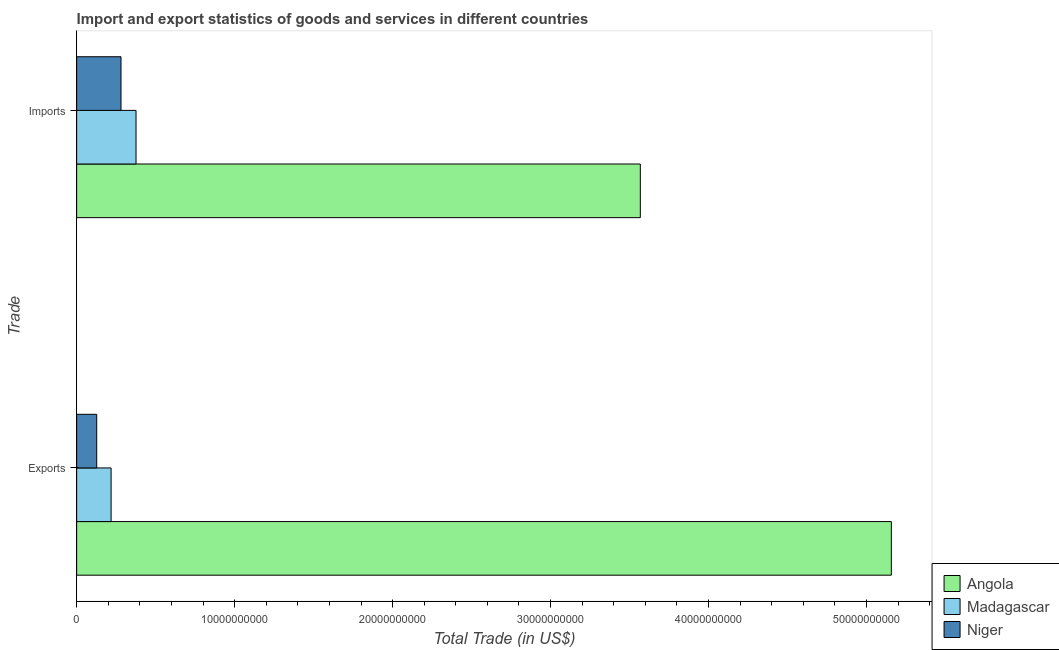How many groups of bars are there?
Provide a short and direct response. 2. Are the number of bars per tick equal to the number of legend labels?
Provide a succinct answer. Yes. Are the number of bars on each tick of the Y-axis equal?
Keep it short and to the point. Yes. How many bars are there on the 2nd tick from the bottom?
Provide a succinct answer. 3. What is the label of the 1st group of bars from the top?
Provide a succinct answer. Imports. What is the imports of goods and services in Madagascar?
Make the answer very short. 3.76e+09. Across all countries, what is the maximum imports of goods and services?
Keep it short and to the point. 3.57e+1. Across all countries, what is the minimum export of goods and services?
Your response must be concise. 1.27e+09. In which country was the imports of goods and services maximum?
Keep it short and to the point. Angola. In which country was the imports of goods and services minimum?
Make the answer very short. Niger. What is the total export of goods and services in the graph?
Make the answer very short. 5.50e+1. What is the difference between the imports of goods and services in Madagascar and that in Niger?
Your response must be concise. 9.51e+08. What is the difference between the imports of goods and services in Madagascar and the export of goods and services in Niger?
Your answer should be compact. 2.49e+09. What is the average export of goods and services per country?
Make the answer very short. 1.83e+1. What is the difference between the imports of goods and services and export of goods and services in Madagascar?
Your response must be concise. 1.58e+09. In how many countries, is the export of goods and services greater than 14000000000 US$?
Give a very brief answer. 1. What is the ratio of the imports of goods and services in Niger to that in Madagascar?
Your response must be concise. 0.75. In how many countries, is the export of goods and services greater than the average export of goods and services taken over all countries?
Provide a succinct answer. 1. What does the 3rd bar from the top in Exports represents?
Make the answer very short. Angola. What does the 3rd bar from the bottom in Imports represents?
Keep it short and to the point. Niger. How many bars are there?
Provide a short and direct response. 6. Are all the bars in the graph horizontal?
Offer a very short reply. Yes. How many countries are there in the graph?
Your answer should be very brief. 3. What is the difference between two consecutive major ticks on the X-axis?
Offer a terse response. 1.00e+1. Are the values on the major ticks of X-axis written in scientific E-notation?
Provide a short and direct response. No. Does the graph contain any zero values?
Provide a short and direct response. No. Does the graph contain grids?
Your answer should be very brief. No. How many legend labels are there?
Provide a succinct answer. 3. How are the legend labels stacked?
Provide a short and direct response. Vertical. What is the title of the graph?
Your answer should be compact. Import and export statistics of goods and services in different countries. What is the label or title of the X-axis?
Provide a short and direct response. Total Trade (in US$). What is the label or title of the Y-axis?
Offer a terse response. Trade. What is the Total Trade (in US$) in Angola in Exports?
Give a very brief answer. 5.16e+1. What is the Total Trade (in US$) in Madagascar in Exports?
Offer a terse response. 2.18e+09. What is the Total Trade (in US$) of Niger in Exports?
Ensure brevity in your answer.  1.27e+09. What is the Total Trade (in US$) in Angola in Imports?
Your answer should be very brief. 3.57e+1. What is the Total Trade (in US$) of Madagascar in Imports?
Your response must be concise. 3.76e+09. What is the Total Trade (in US$) in Niger in Imports?
Offer a terse response. 2.81e+09. Across all Trade, what is the maximum Total Trade (in US$) in Angola?
Ensure brevity in your answer.  5.16e+1. Across all Trade, what is the maximum Total Trade (in US$) in Madagascar?
Offer a terse response. 3.76e+09. Across all Trade, what is the maximum Total Trade (in US$) in Niger?
Your answer should be compact. 2.81e+09. Across all Trade, what is the minimum Total Trade (in US$) in Angola?
Provide a succinct answer. 3.57e+1. Across all Trade, what is the minimum Total Trade (in US$) in Madagascar?
Offer a very short reply. 2.18e+09. Across all Trade, what is the minimum Total Trade (in US$) of Niger?
Ensure brevity in your answer.  1.27e+09. What is the total Total Trade (in US$) of Angola in the graph?
Ensure brevity in your answer.  8.73e+1. What is the total Total Trade (in US$) of Madagascar in the graph?
Your response must be concise. 5.94e+09. What is the total Total Trade (in US$) of Niger in the graph?
Offer a very short reply. 4.08e+09. What is the difference between the Total Trade (in US$) in Angola in Exports and that in Imports?
Offer a terse response. 1.59e+1. What is the difference between the Total Trade (in US$) in Madagascar in Exports and that in Imports?
Ensure brevity in your answer.  -1.58e+09. What is the difference between the Total Trade (in US$) of Niger in Exports and that in Imports?
Your response must be concise. -1.54e+09. What is the difference between the Total Trade (in US$) of Angola in Exports and the Total Trade (in US$) of Madagascar in Imports?
Keep it short and to the point. 4.78e+1. What is the difference between the Total Trade (in US$) of Angola in Exports and the Total Trade (in US$) of Niger in Imports?
Give a very brief answer. 4.88e+1. What is the difference between the Total Trade (in US$) of Madagascar in Exports and the Total Trade (in US$) of Niger in Imports?
Your response must be concise. -6.27e+08. What is the average Total Trade (in US$) of Angola per Trade?
Offer a terse response. 4.36e+1. What is the average Total Trade (in US$) of Madagascar per Trade?
Your response must be concise. 2.97e+09. What is the average Total Trade (in US$) in Niger per Trade?
Offer a terse response. 2.04e+09. What is the difference between the Total Trade (in US$) of Angola and Total Trade (in US$) of Madagascar in Exports?
Give a very brief answer. 4.94e+1. What is the difference between the Total Trade (in US$) in Angola and Total Trade (in US$) in Niger in Exports?
Offer a very short reply. 5.03e+1. What is the difference between the Total Trade (in US$) in Madagascar and Total Trade (in US$) in Niger in Exports?
Offer a terse response. 9.11e+08. What is the difference between the Total Trade (in US$) of Angola and Total Trade (in US$) of Madagascar in Imports?
Make the answer very short. 3.19e+1. What is the difference between the Total Trade (in US$) of Angola and Total Trade (in US$) of Niger in Imports?
Provide a succinct answer. 3.29e+1. What is the difference between the Total Trade (in US$) of Madagascar and Total Trade (in US$) of Niger in Imports?
Give a very brief answer. 9.51e+08. What is the ratio of the Total Trade (in US$) of Angola in Exports to that in Imports?
Ensure brevity in your answer.  1.45. What is the ratio of the Total Trade (in US$) in Madagascar in Exports to that in Imports?
Make the answer very short. 0.58. What is the ratio of the Total Trade (in US$) in Niger in Exports to that in Imports?
Provide a succinct answer. 0.45. What is the difference between the highest and the second highest Total Trade (in US$) of Angola?
Provide a succinct answer. 1.59e+1. What is the difference between the highest and the second highest Total Trade (in US$) of Madagascar?
Offer a very short reply. 1.58e+09. What is the difference between the highest and the second highest Total Trade (in US$) of Niger?
Your response must be concise. 1.54e+09. What is the difference between the highest and the lowest Total Trade (in US$) in Angola?
Ensure brevity in your answer.  1.59e+1. What is the difference between the highest and the lowest Total Trade (in US$) in Madagascar?
Provide a succinct answer. 1.58e+09. What is the difference between the highest and the lowest Total Trade (in US$) of Niger?
Ensure brevity in your answer.  1.54e+09. 